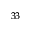Convert formula to latex. <formula><loc_0><loc_0><loc_500><loc_500>^ { 3 3 }</formula> 